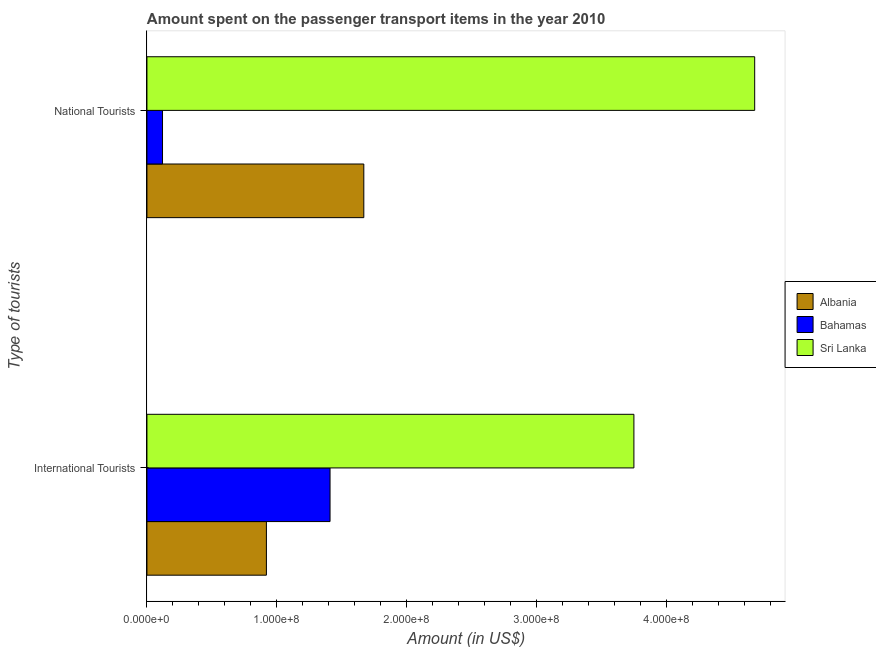How many different coloured bars are there?
Your response must be concise. 3. How many groups of bars are there?
Ensure brevity in your answer.  2. Are the number of bars on each tick of the Y-axis equal?
Your answer should be very brief. Yes. How many bars are there on the 2nd tick from the top?
Provide a succinct answer. 3. What is the label of the 2nd group of bars from the top?
Offer a very short reply. International Tourists. What is the amount spent on transport items of international tourists in Bahamas?
Provide a succinct answer. 1.41e+08. Across all countries, what is the maximum amount spent on transport items of international tourists?
Make the answer very short. 3.75e+08. Across all countries, what is the minimum amount spent on transport items of international tourists?
Make the answer very short. 9.20e+07. In which country was the amount spent on transport items of national tourists maximum?
Make the answer very short. Sri Lanka. In which country was the amount spent on transport items of national tourists minimum?
Offer a terse response. Bahamas. What is the total amount spent on transport items of national tourists in the graph?
Your answer should be compact. 6.47e+08. What is the difference between the amount spent on transport items of international tourists in Albania and that in Bahamas?
Provide a short and direct response. -4.90e+07. What is the difference between the amount spent on transport items of national tourists in Sri Lanka and the amount spent on transport items of international tourists in Albania?
Make the answer very short. 3.76e+08. What is the average amount spent on transport items of national tourists per country?
Provide a short and direct response. 2.16e+08. What is the difference between the amount spent on transport items of international tourists and amount spent on transport items of national tourists in Albania?
Offer a terse response. -7.50e+07. What is the ratio of the amount spent on transport items of international tourists in Albania to that in Sri Lanka?
Provide a succinct answer. 0.25. Is the amount spent on transport items of international tourists in Bahamas less than that in Albania?
Offer a very short reply. No. What does the 3rd bar from the top in National Tourists represents?
Make the answer very short. Albania. What does the 2nd bar from the bottom in International Tourists represents?
Make the answer very short. Bahamas. What is the difference between two consecutive major ticks on the X-axis?
Ensure brevity in your answer.  1.00e+08. Does the graph contain grids?
Ensure brevity in your answer.  No. Where does the legend appear in the graph?
Keep it short and to the point. Center right. How many legend labels are there?
Your response must be concise. 3. How are the legend labels stacked?
Provide a succinct answer. Vertical. What is the title of the graph?
Give a very brief answer. Amount spent on the passenger transport items in the year 2010. Does "Lithuania" appear as one of the legend labels in the graph?
Provide a succinct answer. No. What is the label or title of the Y-axis?
Your answer should be very brief. Type of tourists. What is the Amount (in US$) in Albania in International Tourists?
Provide a short and direct response. 9.20e+07. What is the Amount (in US$) of Bahamas in International Tourists?
Your answer should be very brief. 1.41e+08. What is the Amount (in US$) of Sri Lanka in International Tourists?
Provide a short and direct response. 3.75e+08. What is the Amount (in US$) of Albania in National Tourists?
Offer a very short reply. 1.67e+08. What is the Amount (in US$) in Bahamas in National Tourists?
Make the answer very short. 1.20e+07. What is the Amount (in US$) of Sri Lanka in National Tourists?
Give a very brief answer. 4.68e+08. Across all Type of tourists, what is the maximum Amount (in US$) of Albania?
Offer a very short reply. 1.67e+08. Across all Type of tourists, what is the maximum Amount (in US$) in Bahamas?
Ensure brevity in your answer.  1.41e+08. Across all Type of tourists, what is the maximum Amount (in US$) of Sri Lanka?
Your response must be concise. 4.68e+08. Across all Type of tourists, what is the minimum Amount (in US$) of Albania?
Your response must be concise. 9.20e+07. Across all Type of tourists, what is the minimum Amount (in US$) of Sri Lanka?
Ensure brevity in your answer.  3.75e+08. What is the total Amount (in US$) in Albania in the graph?
Give a very brief answer. 2.59e+08. What is the total Amount (in US$) of Bahamas in the graph?
Give a very brief answer. 1.53e+08. What is the total Amount (in US$) in Sri Lanka in the graph?
Your answer should be compact. 8.43e+08. What is the difference between the Amount (in US$) in Albania in International Tourists and that in National Tourists?
Your response must be concise. -7.50e+07. What is the difference between the Amount (in US$) in Bahamas in International Tourists and that in National Tourists?
Offer a very short reply. 1.29e+08. What is the difference between the Amount (in US$) of Sri Lanka in International Tourists and that in National Tourists?
Offer a very short reply. -9.30e+07. What is the difference between the Amount (in US$) of Albania in International Tourists and the Amount (in US$) of Bahamas in National Tourists?
Offer a terse response. 8.00e+07. What is the difference between the Amount (in US$) of Albania in International Tourists and the Amount (in US$) of Sri Lanka in National Tourists?
Give a very brief answer. -3.76e+08. What is the difference between the Amount (in US$) of Bahamas in International Tourists and the Amount (in US$) of Sri Lanka in National Tourists?
Provide a short and direct response. -3.27e+08. What is the average Amount (in US$) of Albania per Type of tourists?
Give a very brief answer. 1.30e+08. What is the average Amount (in US$) in Bahamas per Type of tourists?
Give a very brief answer. 7.65e+07. What is the average Amount (in US$) in Sri Lanka per Type of tourists?
Your answer should be compact. 4.22e+08. What is the difference between the Amount (in US$) of Albania and Amount (in US$) of Bahamas in International Tourists?
Provide a short and direct response. -4.90e+07. What is the difference between the Amount (in US$) in Albania and Amount (in US$) in Sri Lanka in International Tourists?
Provide a short and direct response. -2.83e+08. What is the difference between the Amount (in US$) of Bahamas and Amount (in US$) of Sri Lanka in International Tourists?
Ensure brevity in your answer.  -2.34e+08. What is the difference between the Amount (in US$) of Albania and Amount (in US$) of Bahamas in National Tourists?
Make the answer very short. 1.55e+08. What is the difference between the Amount (in US$) in Albania and Amount (in US$) in Sri Lanka in National Tourists?
Provide a succinct answer. -3.01e+08. What is the difference between the Amount (in US$) in Bahamas and Amount (in US$) in Sri Lanka in National Tourists?
Your answer should be very brief. -4.56e+08. What is the ratio of the Amount (in US$) of Albania in International Tourists to that in National Tourists?
Provide a short and direct response. 0.55. What is the ratio of the Amount (in US$) in Bahamas in International Tourists to that in National Tourists?
Provide a succinct answer. 11.75. What is the ratio of the Amount (in US$) of Sri Lanka in International Tourists to that in National Tourists?
Make the answer very short. 0.8. What is the difference between the highest and the second highest Amount (in US$) in Albania?
Make the answer very short. 7.50e+07. What is the difference between the highest and the second highest Amount (in US$) of Bahamas?
Keep it short and to the point. 1.29e+08. What is the difference between the highest and the second highest Amount (in US$) of Sri Lanka?
Keep it short and to the point. 9.30e+07. What is the difference between the highest and the lowest Amount (in US$) in Albania?
Your answer should be very brief. 7.50e+07. What is the difference between the highest and the lowest Amount (in US$) in Bahamas?
Your response must be concise. 1.29e+08. What is the difference between the highest and the lowest Amount (in US$) of Sri Lanka?
Ensure brevity in your answer.  9.30e+07. 